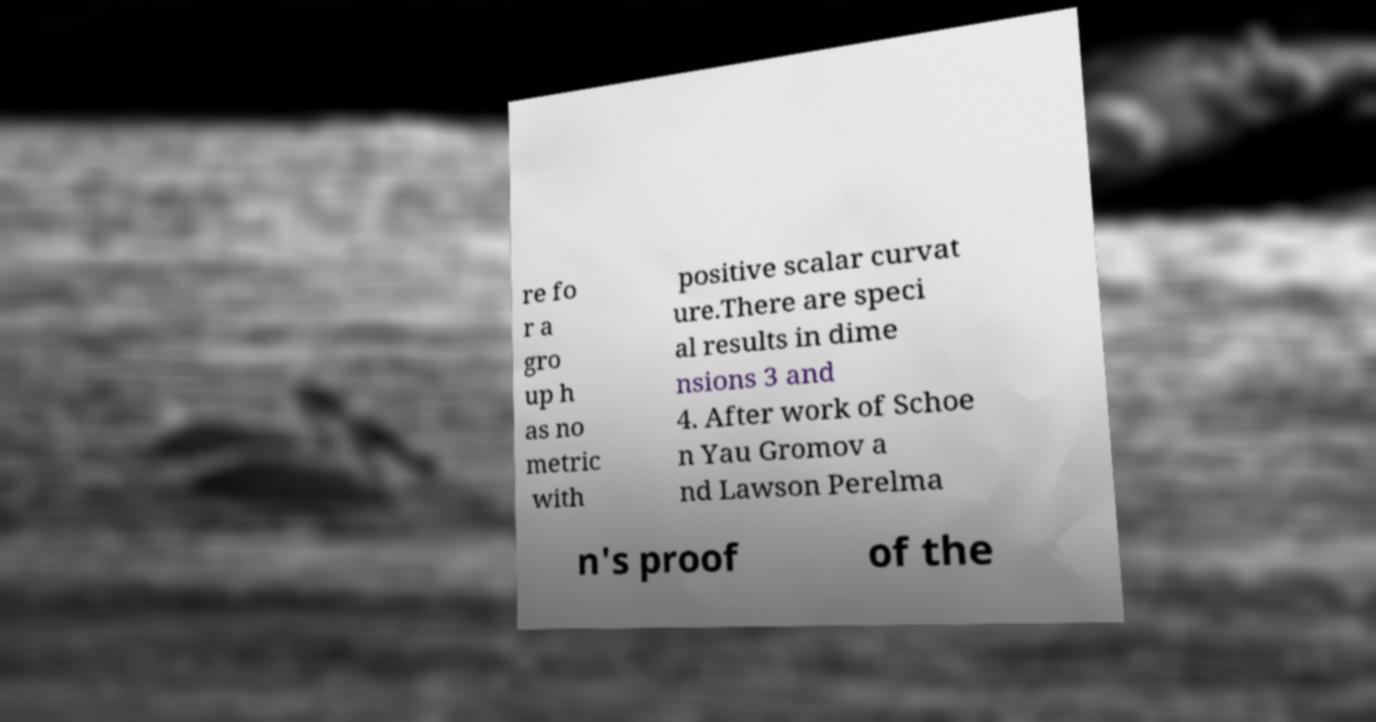Can you read and provide the text displayed in the image?This photo seems to have some interesting text. Can you extract and type it out for me? re fo r a gro up h as no metric with positive scalar curvat ure.There are speci al results in dime nsions 3 and 4. After work of Schoe n Yau Gromov a nd Lawson Perelma n's proof of the 